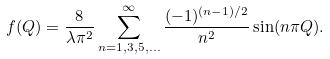Convert formula to latex. <formula><loc_0><loc_0><loc_500><loc_500>f ( Q ) = \frac { 8 } { \lambda \pi ^ { 2 } } \sum _ { n = 1 , 3 , 5 , \dots } ^ { \infty } \frac { ( - 1 ) ^ { ( n - 1 ) / 2 } } { n ^ { 2 } } \sin ( n \pi Q ) .</formula> 